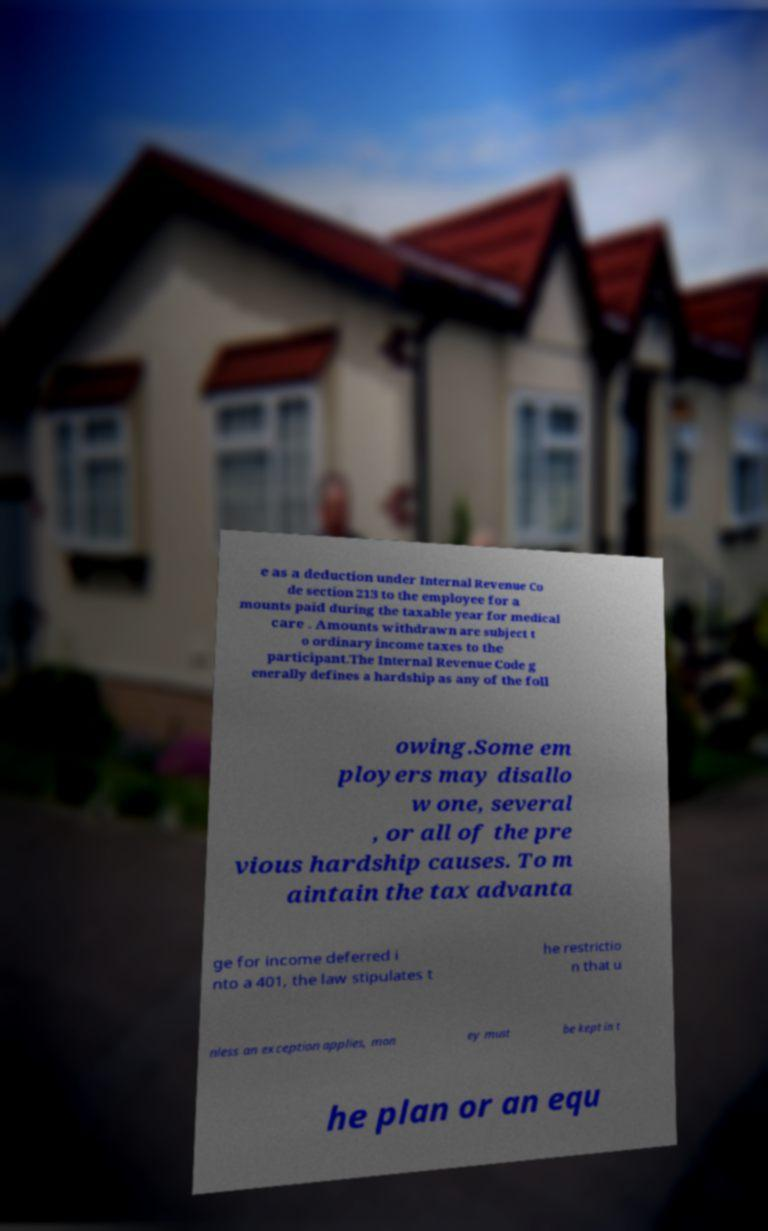Could you extract and type out the text from this image? e as a deduction under Internal Revenue Co de section 213 to the employee for a mounts paid during the taxable year for medical care . Amounts withdrawn are subject t o ordinary income taxes to the participant.The Internal Revenue Code g enerally defines a hardship as any of the foll owing.Some em ployers may disallo w one, several , or all of the pre vious hardship causes. To m aintain the tax advanta ge for income deferred i nto a 401, the law stipulates t he restrictio n that u nless an exception applies, mon ey must be kept in t he plan or an equ 